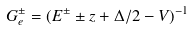<formula> <loc_0><loc_0><loc_500><loc_500>G _ { e } ^ { \pm } = ( E ^ { \pm } \pm z + \Delta / 2 - V ) ^ { - 1 } \</formula> 